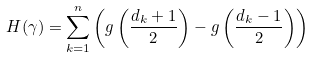<formula> <loc_0><loc_0><loc_500><loc_500>H ( \gamma ) = \sum _ { k = 1 } ^ { n } \left ( g \left ( \frac { d _ { k } + 1 } { 2 } \right ) - g \left ( \frac { d _ { k } - 1 } { 2 } \right ) \right )</formula> 